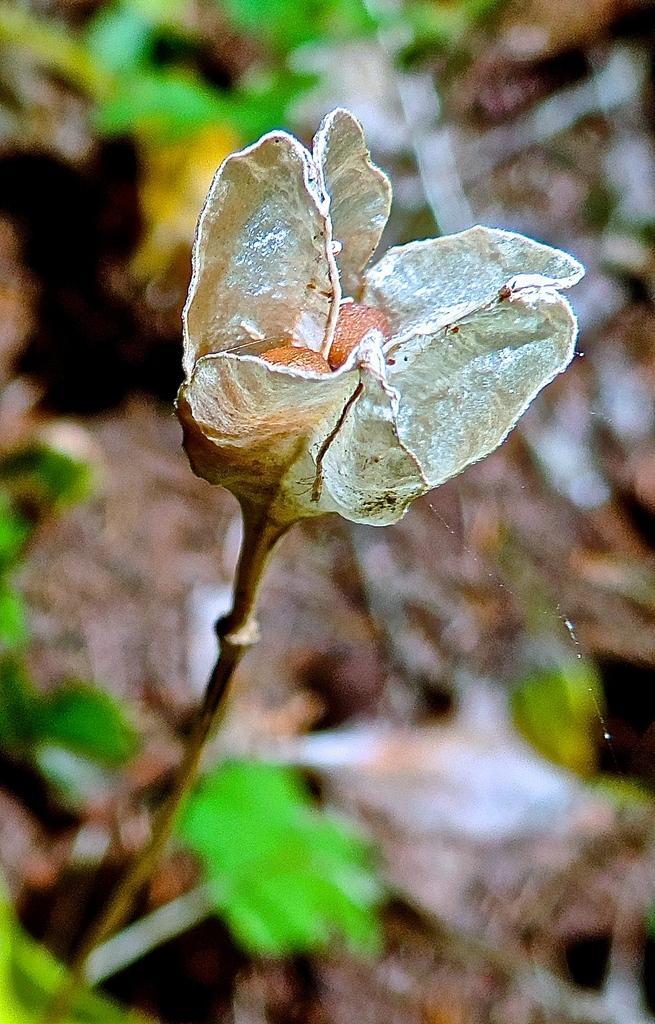Can you describe this image briefly? In this image, in the middle, we can see a flower. In the background, we can see green color and brown color. 